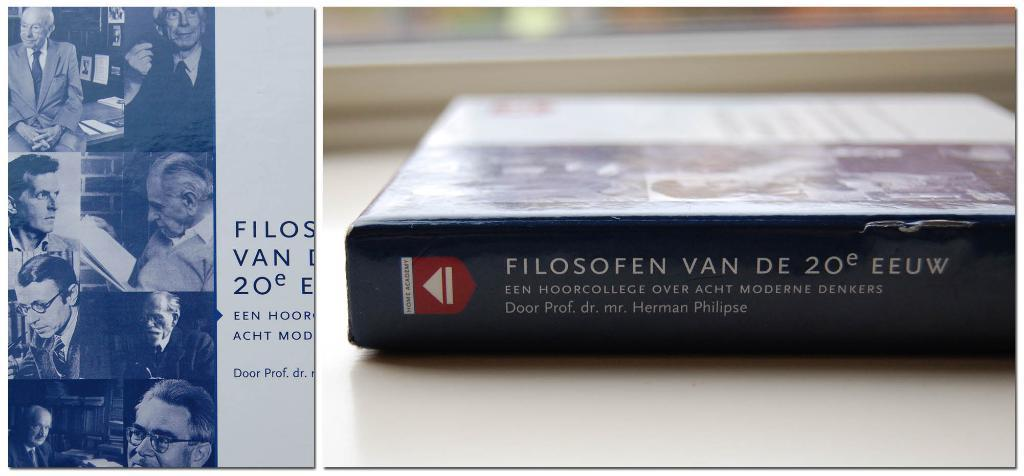Provide a one-sentence caption for the provided image. A book which is by Herman Philipse and has a black spine. 